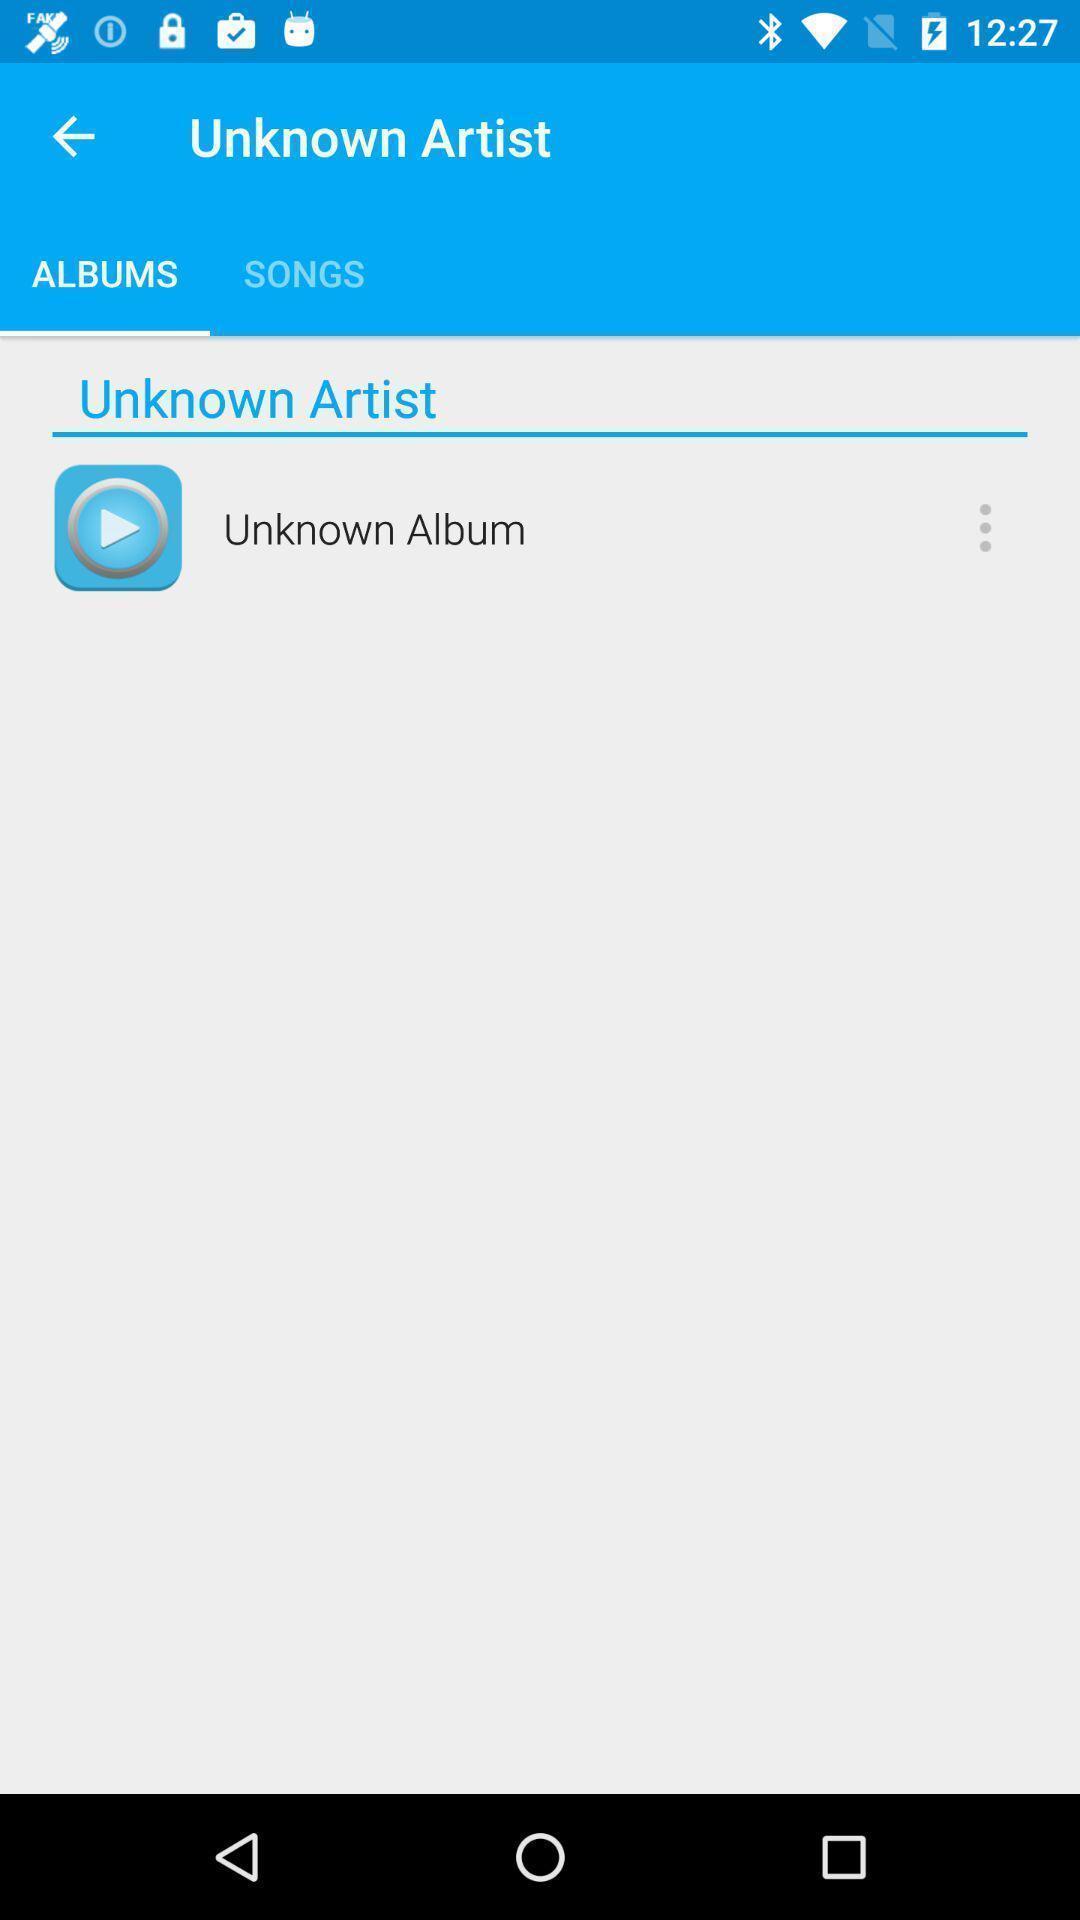Provide a textual representation of this image. Page showing an album on a video player app. 